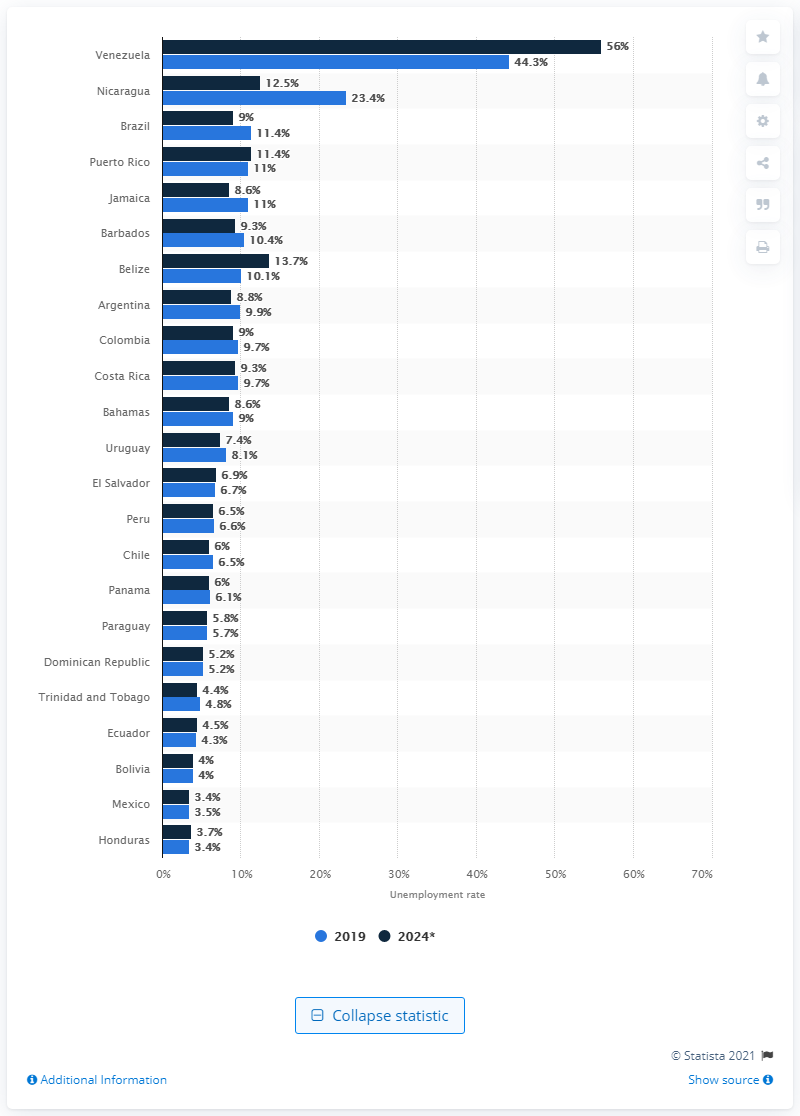Draw attention to some important aspects in this diagram. In 2024, the unemployment rate in Mexico was 3.4%. In April 2019, Venezuela had the highest unemployment rate among all Latin American countries. 